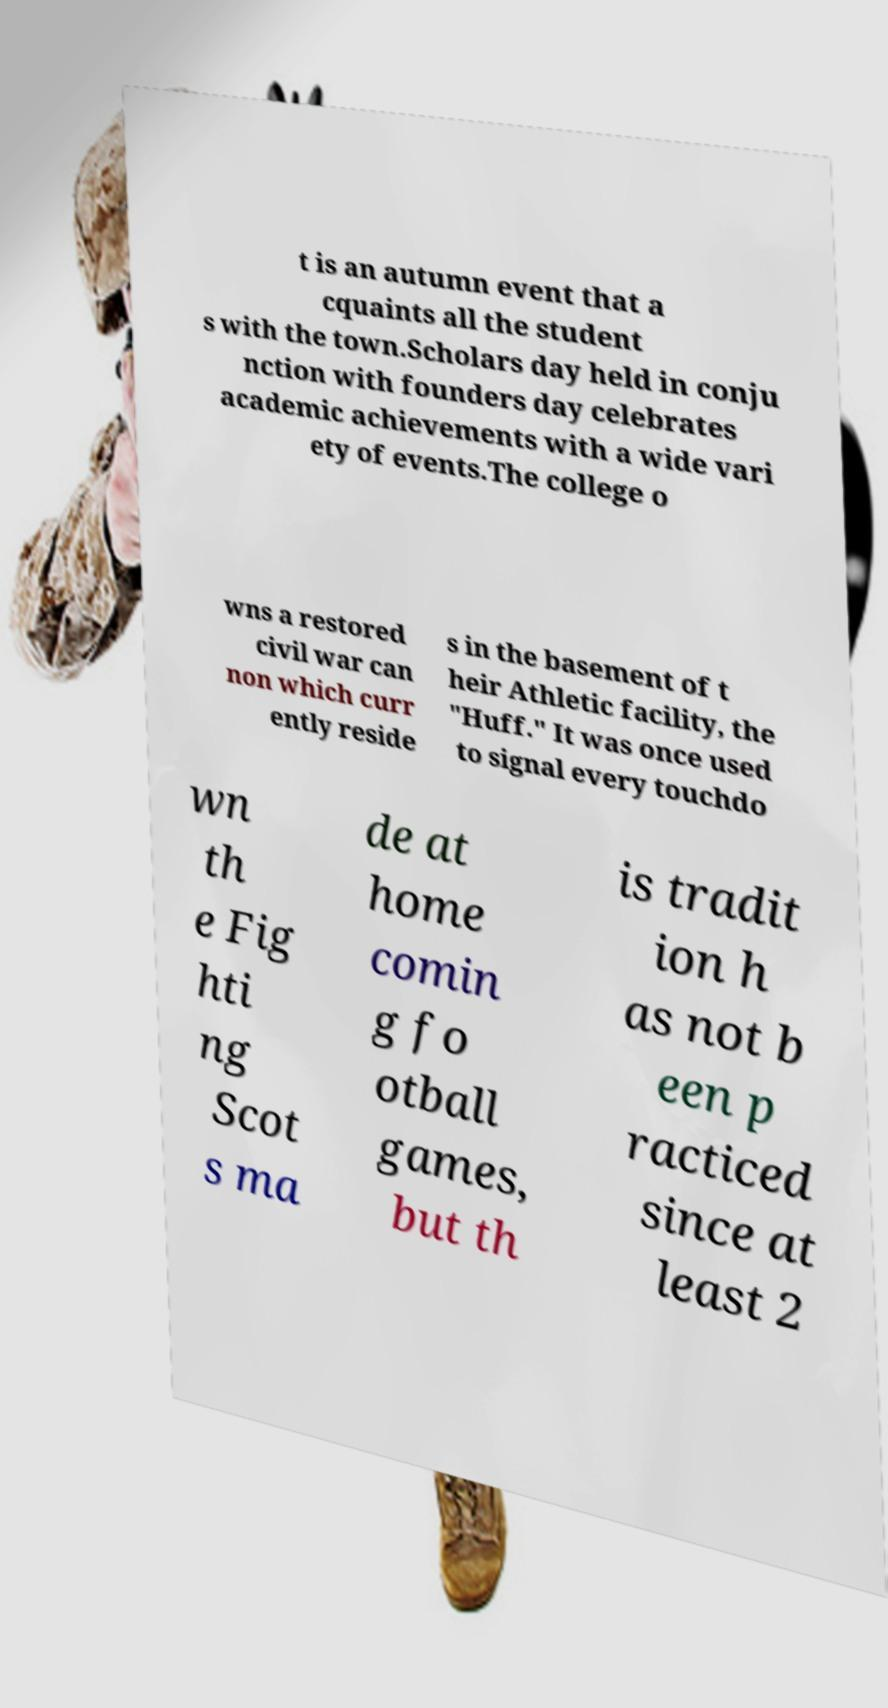Can you read and provide the text displayed in the image?This photo seems to have some interesting text. Can you extract and type it out for me? t is an autumn event that a cquaints all the student s with the town.Scholars day held in conju nction with founders day celebrates academic achievements with a wide vari ety of events.The college o wns a restored civil war can non which curr ently reside s in the basement of t heir Athletic facility, the "Huff." It was once used to signal every touchdo wn th e Fig hti ng Scot s ma de at home comin g fo otball games, but th is tradit ion h as not b een p racticed since at least 2 